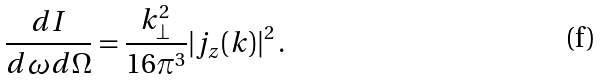<formula> <loc_0><loc_0><loc_500><loc_500>\frac { d I } { d \omega d \Omega } = \frac { k _ { \perp } ^ { 2 } } { 1 6 \pi ^ { 3 } } | j _ { z } ( k ) | ^ { 2 } \, .</formula> 